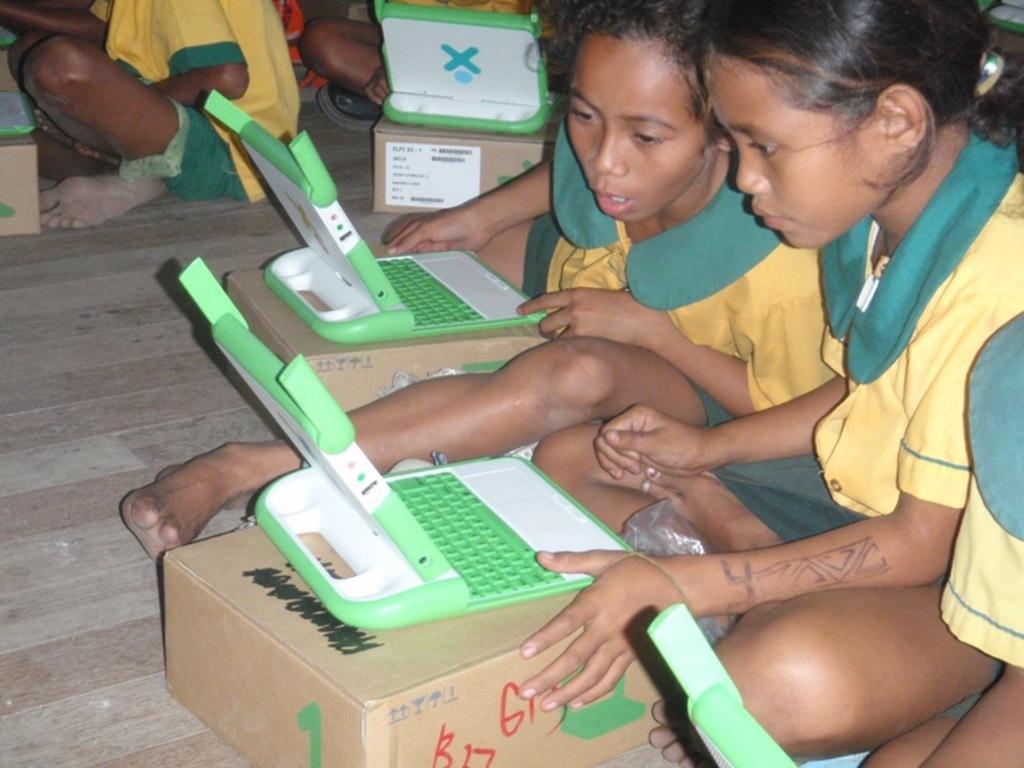In one or two sentences, can you explain what this image depicts? In this image we can see children sitting on the wooden surface. In front of them there are toys on the boxes. At the bottom of the image there is wooden surface. 